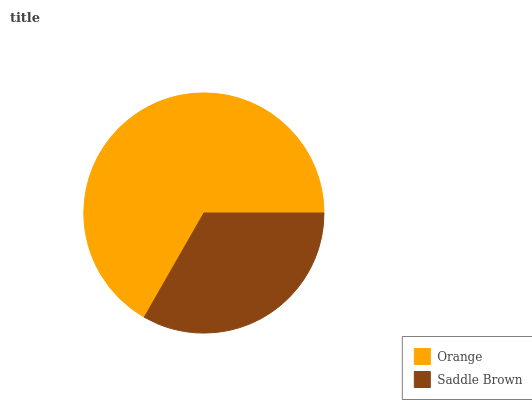Is Saddle Brown the minimum?
Answer yes or no. Yes. Is Orange the maximum?
Answer yes or no. Yes. Is Saddle Brown the maximum?
Answer yes or no. No. Is Orange greater than Saddle Brown?
Answer yes or no. Yes. Is Saddle Brown less than Orange?
Answer yes or no. Yes. Is Saddle Brown greater than Orange?
Answer yes or no. No. Is Orange less than Saddle Brown?
Answer yes or no. No. Is Orange the high median?
Answer yes or no. Yes. Is Saddle Brown the low median?
Answer yes or no. Yes. Is Saddle Brown the high median?
Answer yes or no. No. Is Orange the low median?
Answer yes or no. No. 